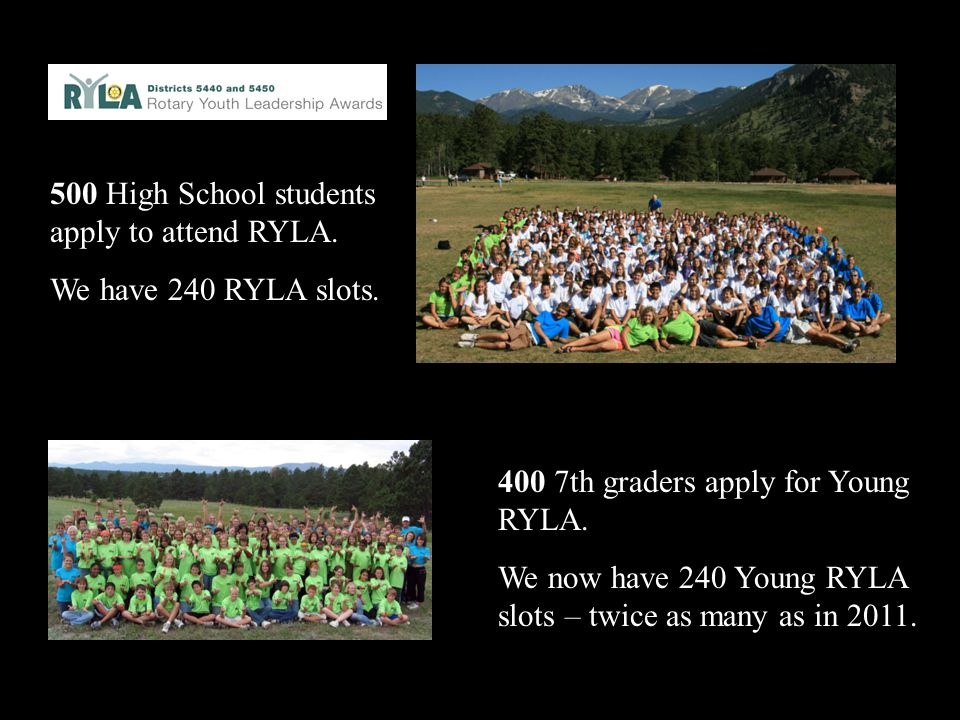Imagine if the camp was visited by a famous astronaut who shared stories of space exploration. How might this inspire the campers? If a famous astronaut visited the camp and shared stories of space exploration, it could be incredibly inspiring for the campers. Hearing first-hand accounts of space missions, challenges faced, and the perseverance required to achieve such extraordinary feats would likely ignite curiosity and ambition in the young participants. It could encourage them to dream big and pursue their passions, no matter how daunting. The astronaut's stories would also highlight the importance of teamwork, dedication, and continuous learning, reinforcing the leadership lessons of the camp. Such an experience could spark interest in STEM (Science, Technology, Engineering, and Math) fields, motivating campers to consider careers they might not have thought possible before. 